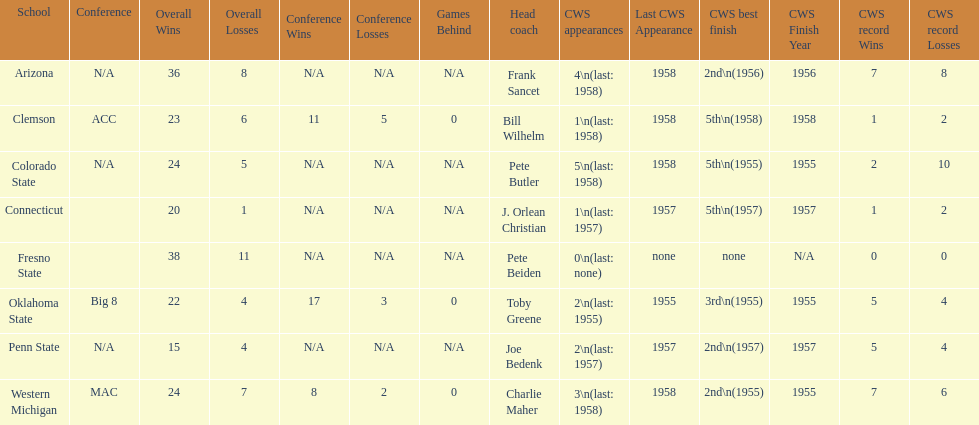Which team did not have more than 16 wins? Penn State. 